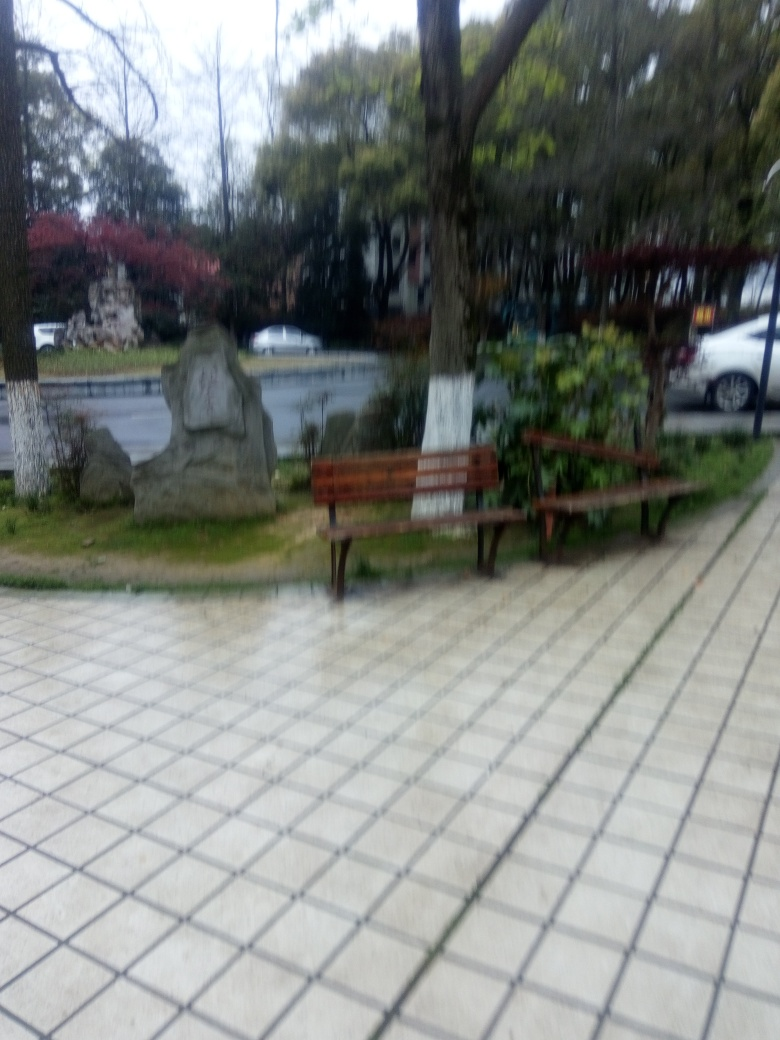Is this a regularly visited park? The presence of well-kept benches, a clean pathway, and what appears to be a car park in the background suggests that the park is maintained, implying that it is likely to be visited regularly by local residents for recreation or leisure. 